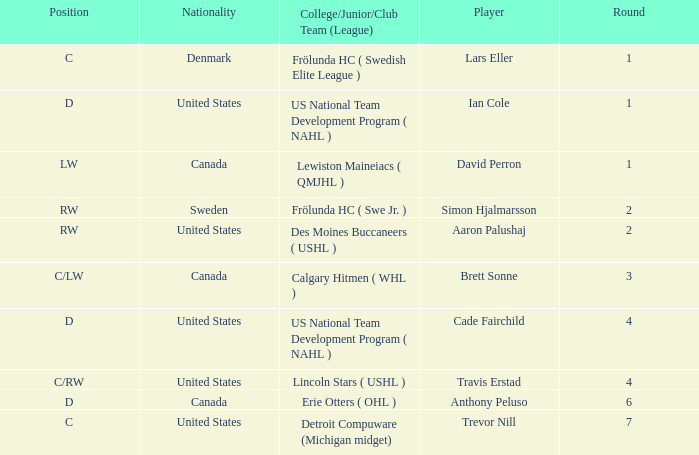What is the highest round of Ian Cole, who played position d from the United States? 1.0. Parse the table in full. {'header': ['Position', 'Nationality', 'College/Junior/Club Team (League)', 'Player', 'Round'], 'rows': [['C', 'Denmark', 'Frölunda HC ( Swedish Elite League )', 'Lars Eller', '1'], ['D', 'United States', 'US National Team Development Program ( NAHL )', 'Ian Cole', '1'], ['LW', 'Canada', 'Lewiston Maineiacs ( QMJHL )', 'David Perron', '1'], ['RW', 'Sweden', 'Frölunda HC ( Swe Jr. )', 'Simon Hjalmarsson', '2'], ['RW', 'United States', 'Des Moines Buccaneers ( USHL )', 'Aaron Palushaj', '2'], ['C/LW', 'Canada', 'Calgary Hitmen ( WHL )', 'Brett Sonne', '3'], ['D', 'United States', 'US National Team Development Program ( NAHL )', 'Cade Fairchild', '4'], ['C/RW', 'United States', 'Lincoln Stars ( USHL )', 'Travis Erstad', '4'], ['D', 'Canada', 'Erie Otters ( OHL )', 'Anthony Peluso', '6'], ['C', 'United States', 'Detroit Compuware (Michigan midget)', 'Trevor Nill', '7']]} 